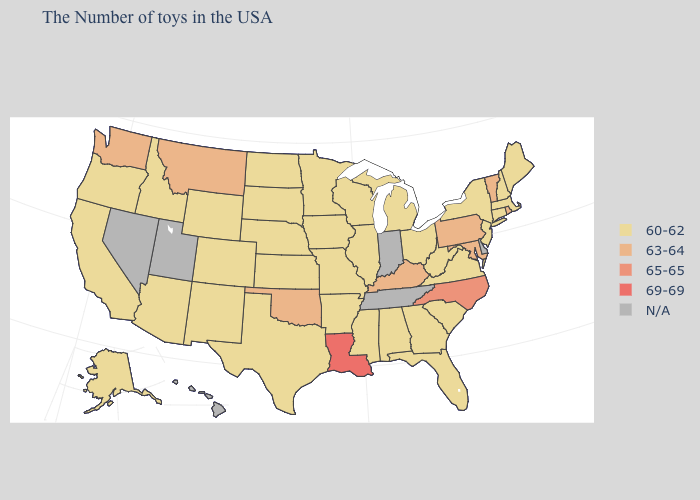What is the highest value in states that border Maryland?
Keep it brief. 63-64. Which states hav the highest value in the South?
Quick response, please. Louisiana. Which states hav the highest value in the Northeast?
Write a very short answer. Rhode Island, Vermont, Pennsylvania. What is the lowest value in the USA?
Quick response, please. 60-62. Name the states that have a value in the range 69-69?
Give a very brief answer. Louisiana. Name the states that have a value in the range N/A?
Be succinct. Delaware, Indiana, Tennessee, Utah, Nevada, Hawaii. Does North Carolina have the lowest value in the USA?
Be succinct. No. Name the states that have a value in the range 60-62?
Give a very brief answer. Maine, Massachusetts, New Hampshire, Connecticut, New York, New Jersey, Virginia, South Carolina, West Virginia, Ohio, Florida, Georgia, Michigan, Alabama, Wisconsin, Illinois, Mississippi, Missouri, Arkansas, Minnesota, Iowa, Kansas, Nebraska, Texas, South Dakota, North Dakota, Wyoming, Colorado, New Mexico, Arizona, Idaho, California, Oregon, Alaska. What is the lowest value in states that border New Mexico?
Be succinct. 60-62. What is the value of Colorado?
Answer briefly. 60-62. What is the value of Massachusetts?
Keep it brief. 60-62. Name the states that have a value in the range N/A?
Be succinct. Delaware, Indiana, Tennessee, Utah, Nevada, Hawaii. Does Louisiana have the highest value in the USA?
Answer briefly. Yes. How many symbols are there in the legend?
Answer briefly. 5. 